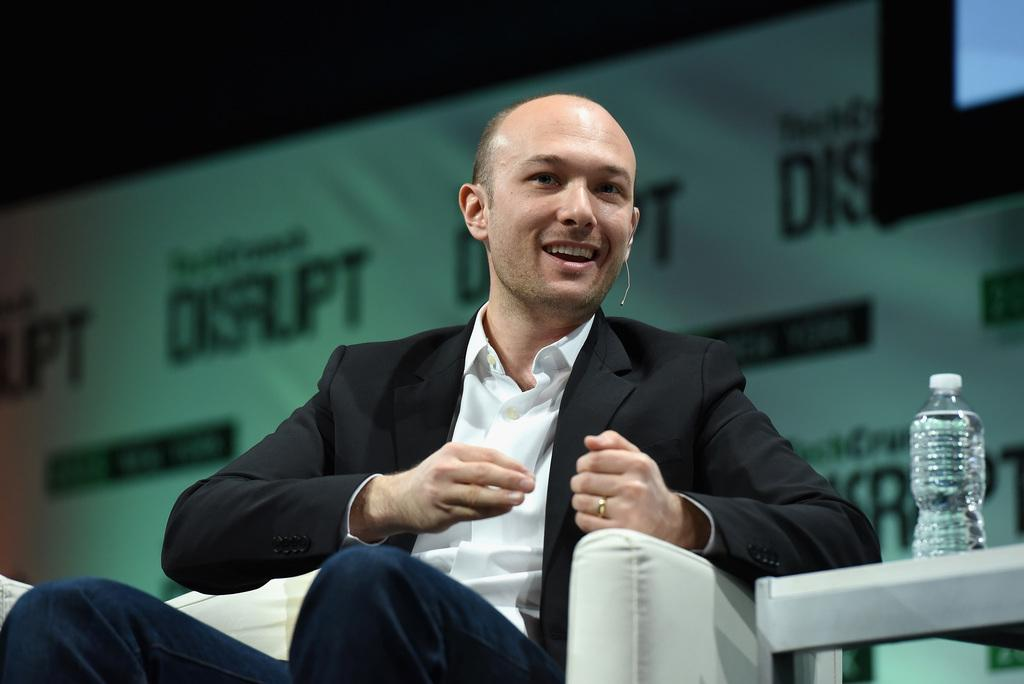What is the main subject in the center of the image? There is a man sitting in the center of the image. What can be seen on the right side of the image? There is a stand on the right side of the image, and a bottle is placed on it. What is visible in the background of the image? There is a screen and a board in the background of the image. What type of spoon is being used to say good-bye to the man in the image? There is no spoon or good-bye gesture present in the image. 